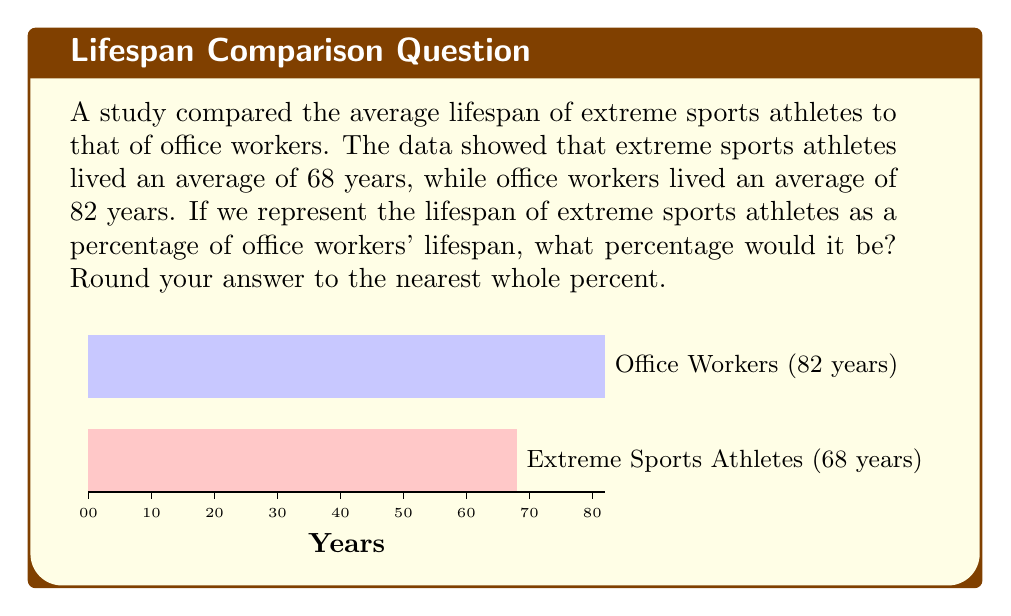Teach me how to tackle this problem. To calculate the percentage, we need to:

1. Set up the ratio of extreme sports athletes' lifespan to office workers' lifespan.
2. Convert this ratio to a percentage.
3. Round to the nearest whole percent.

Step 1: Set up the ratio
$$\frac{\text{Extreme sports athletes' lifespan}}{\text{Office workers' lifespan}} = \frac{68}{82}$$

Step 2: Convert to percentage
To convert a ratio to a percentage, we multiply by 100:

$$\frac{68}{82} \times 100 = 82.926829...\%$$

Step 3: Round to the nearest whole percent
82.926829... rounds to 83%

Therefore, the lifespan of extreme sports athletes is approximately 83% of the lifespan of office workers.
Answer: 83% 